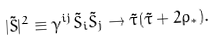<formula> <loc_0><loc_0><loc_500><loc_500>| \tilde { S } | ^ { 2 } \equiv \gamma ^ { i j } \tilde { S } _ { i } \tilde { S } _ { j } \rightarrow \tilde { \tau } ( \tilde { \tau } + 2 \rho _ { * } ) .</formula> 